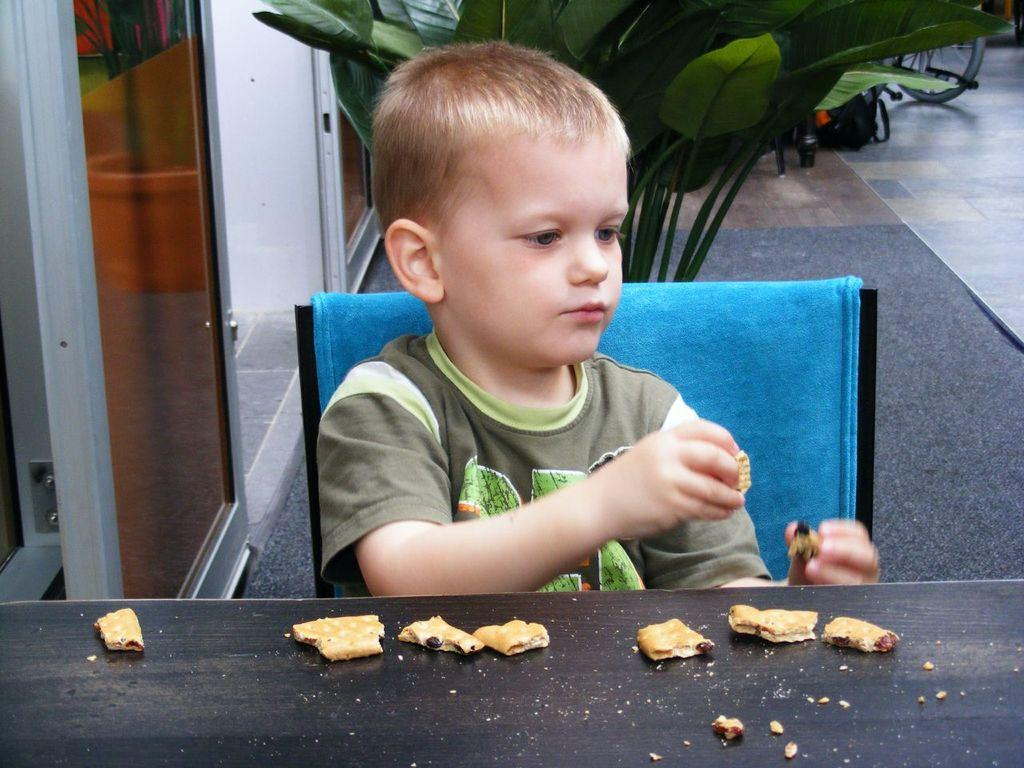What piece of furniture is present in the image? There is a table in the image. What type of food can be seen on the table? There are biscuits on the table. What is the boy in the image doing? The boy is sitting on a chair in the image. Where is the boy positioned in relation to the table? The boy is behind the table. What can be seen in the background of the image? There is a plant in the background of the image. What type of collar can be seen on the plant in the image? There is no collar present on the plant in the image; it is a plant, not an animal. What level of difficulty is the needlework project on the table in the image? There is no needlework project visible on the table in the image. 